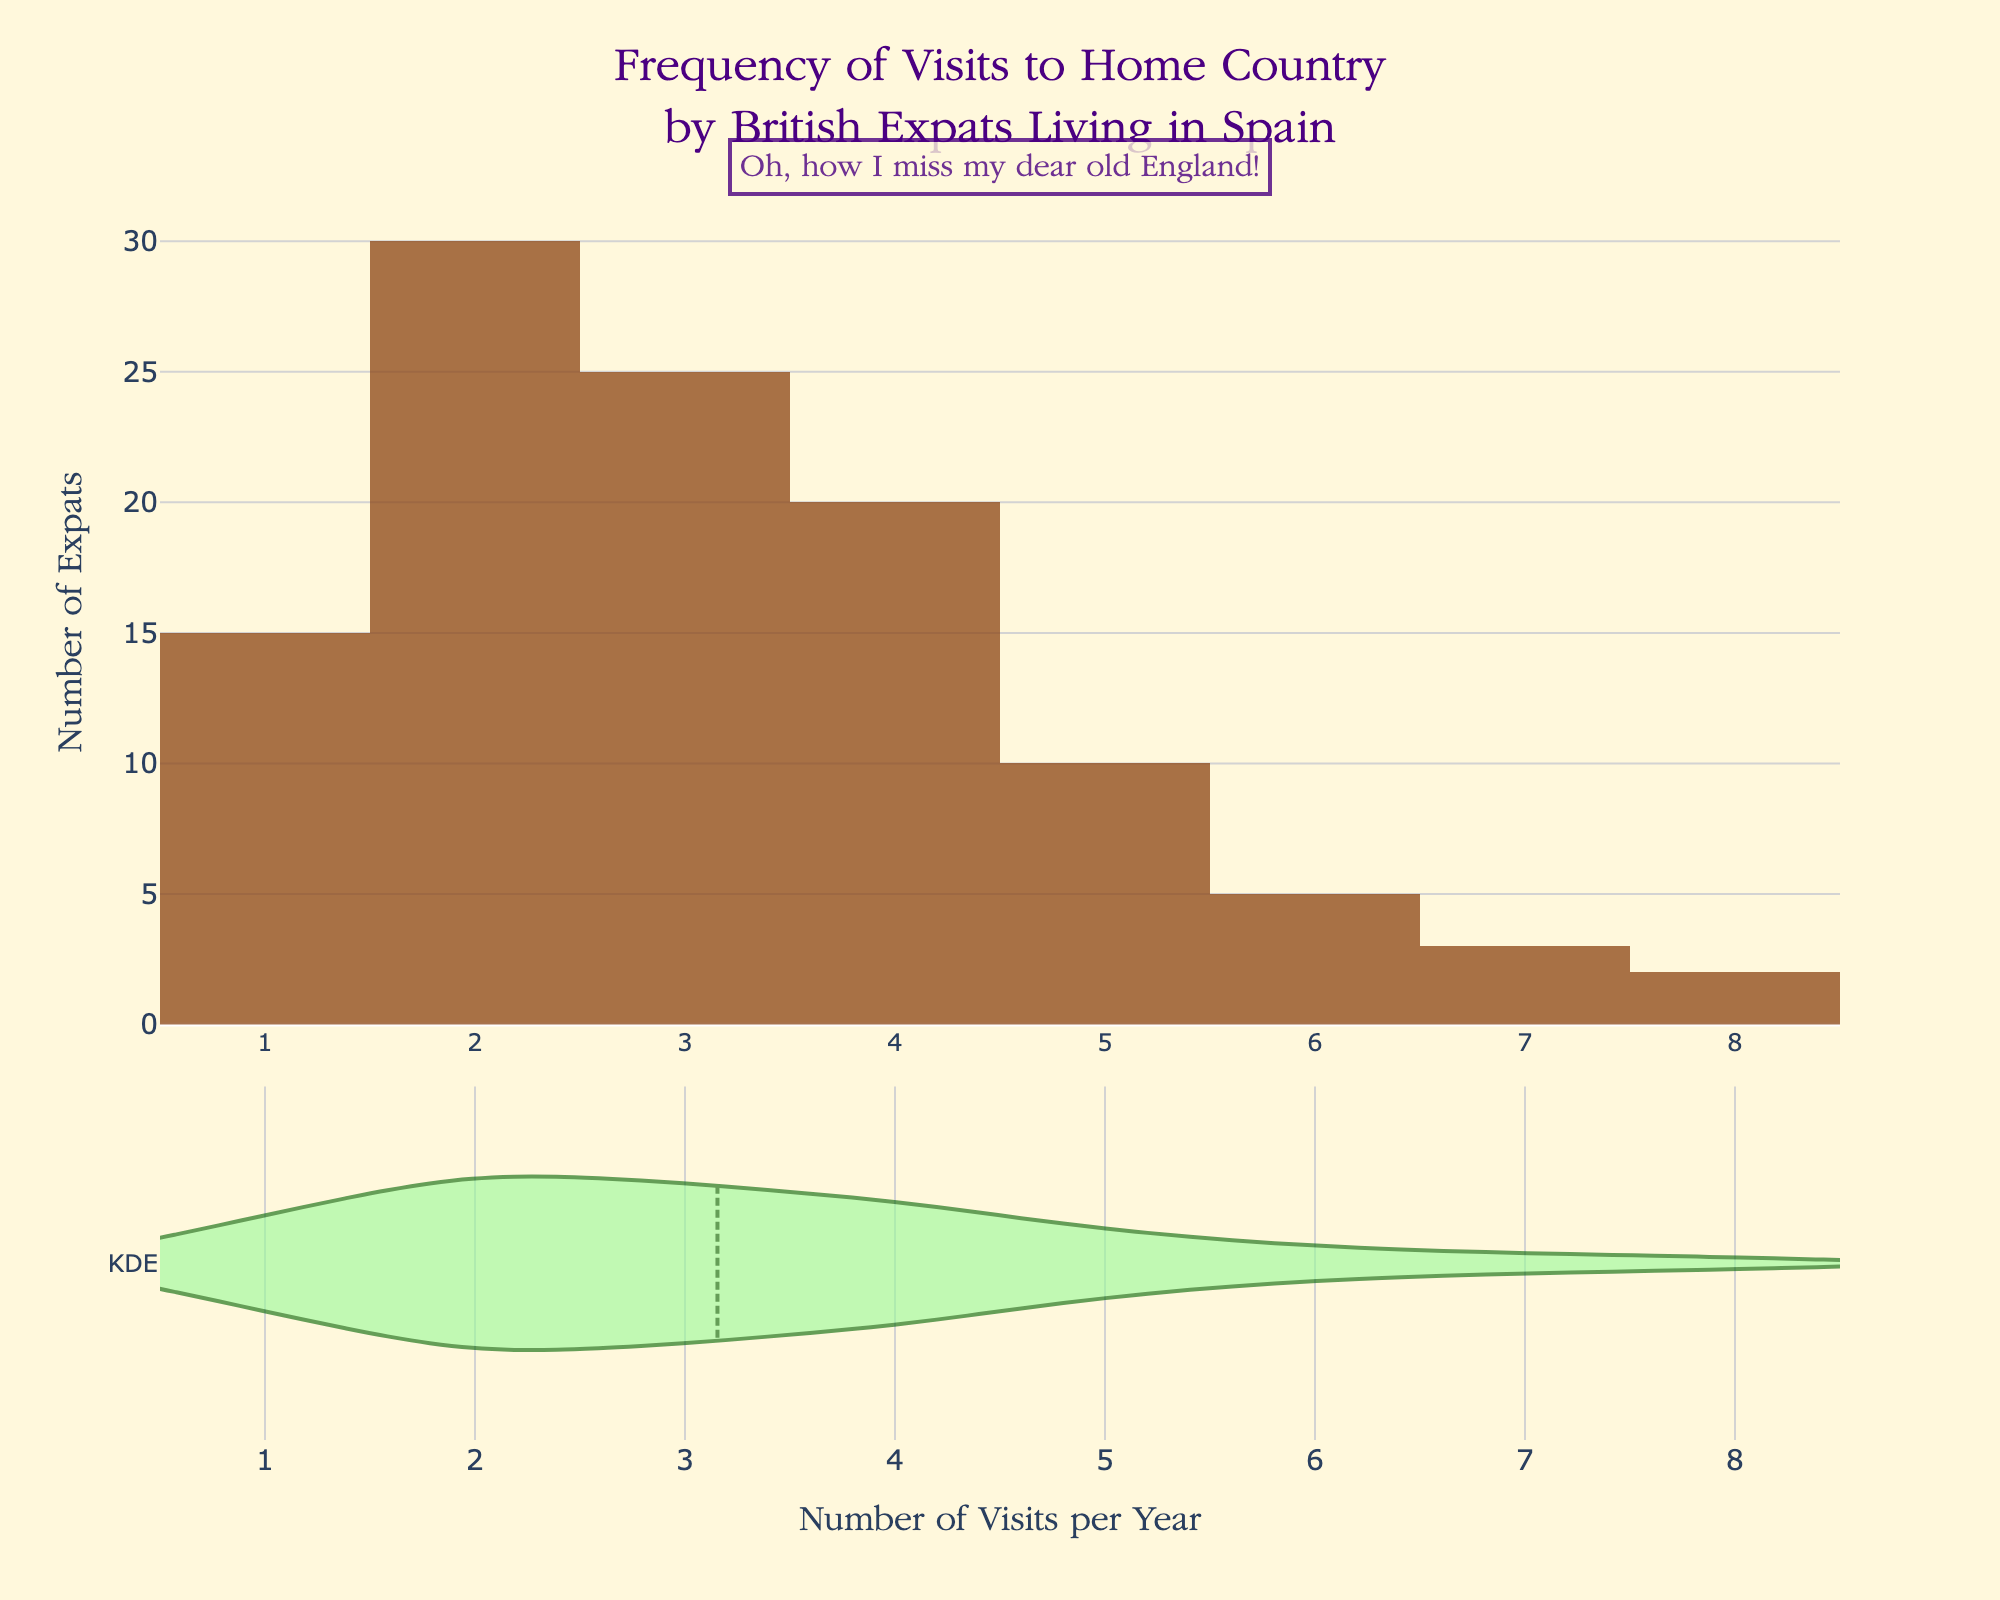How many British expats visit their home country exactly once per year? According to the histogram, the bar corresponding to 1 visit has a height of 15, indicating that 15 expats visit their home country once per year.
Answer: 15 What is the most common number of visits per year by British expats? The highest bar in the histogram represents the most common number of visits. The bar for 2 visits per year is the tallest, indicating that it is the most common.
Answer: 2 visits Which visit frequency has the least number of British expats? The smallest bars in the histogram correspond to 8 visits and 7 visits per year, with both visit frequencies having the least number of expats.
Answer: 8 visits, 7 visits What is the combined total number of expats who visit their home country 5 or more times per year? Adding the number of expats for 5, 6, 7, and 8 visits per year (10 + 5 + 3 + 2) = 20 expats.
Answer: 20 How does the number of expats visiting home 4 times per year compare to those visiting 3 times per year? The bar for 4 visits has a height of 20, while the bar for 3 visits has a height of 25. Therefore, 3 visits per year is more common.
Answer: 3 visits > 4 visits What's the title of the figure? The title is prominently displayed above the figure and reads "Frequency of Visits to Home Country by British Expats Living in Spain."
Answer: Frequency of Visits to Home Country by British Expats Living in Spain What does the x-axis represent? The x-axis, labeled "Number of Visits per Year," represents the frequency of visits to the home country by British expats.
Answer: Number of Visits per Year Approximately how many expats visit their home country more than three times a year? Summing the number of expats for 4, 5, 6, 7, and 8 visits per year (20 + 10 + 5 + 3 + 2) gives approximately 40 expats.
Answer: ~40 What is indicated by the annotation at the top? The annotation reads "Oh, how I miss my dear old England!" which adds a personal touch, reflecting the sentiment of nostalgia.
Answer: Nostalgia How does the distribution spread in the KDE plot compare to the histogram? The KDE plot below the histogram provides a smooth curve to represent the distribution of visit frequencies, showing a peak around 2 visits, similar to the histogram. Both representations highlight that 2 visits per year is the most common frequency.
Answer: Both peak at 2 visits 